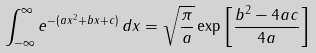<formula> <loc_0><loc_0><loc_500><loc_500>\int _ { - \infty } ^ { \infty } e ^ { - ( a x ^ { 2 } + b x + c ) } \, d x = { \sqrt { \frac { \pi } { a } } } \exp \left [ { \frac { b ^ { 2 } - 4 a c } { 4 a } } \right ]</formula> 